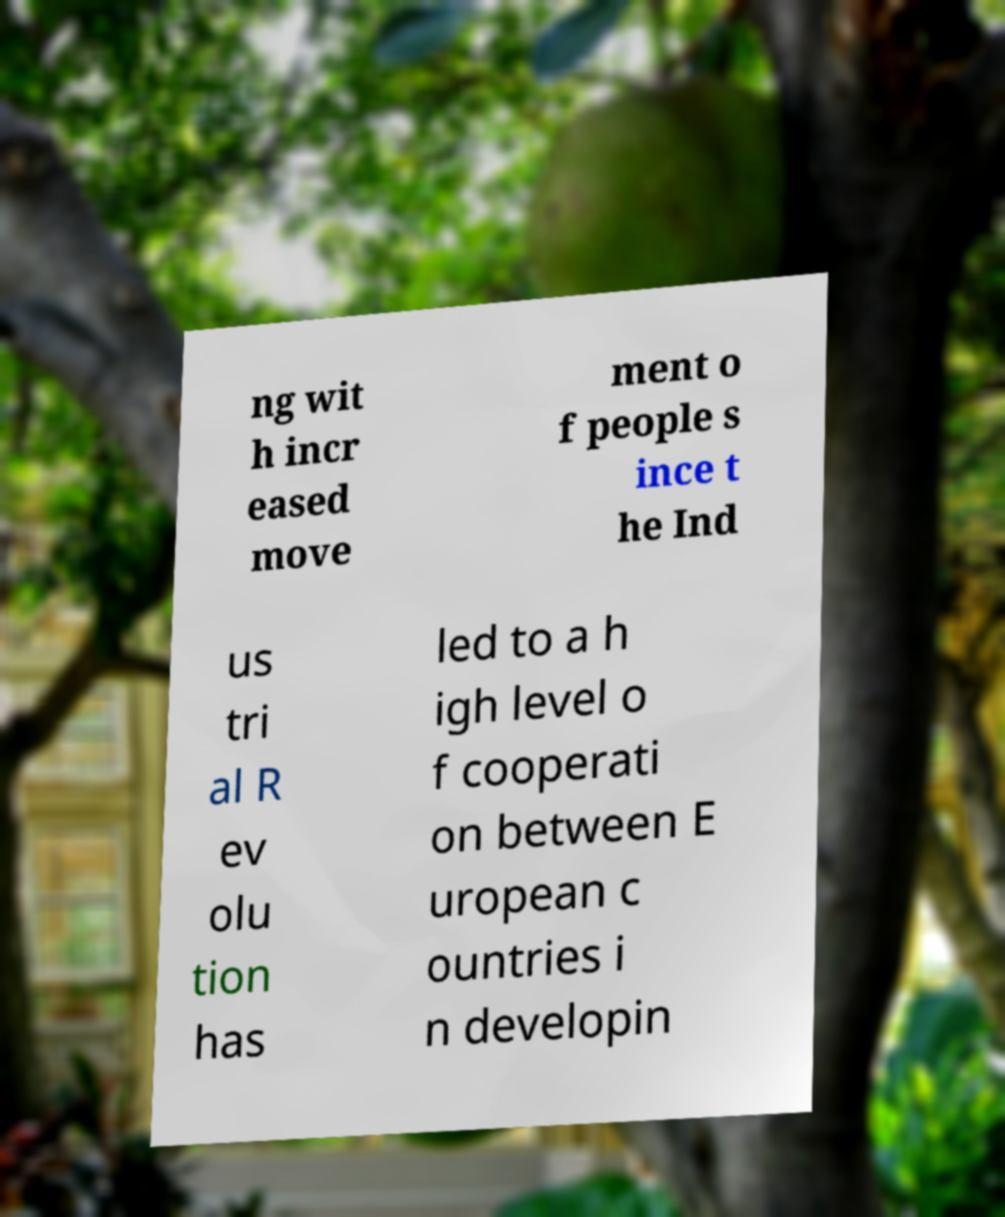I need the written content from this picture converted into text. Can you do that? ng wit h incr eased move ment o f people s ince t he Ind us tri al R ev olu tion has led to a h igh level o f cooperati on between E uropean c ountries i n developin 